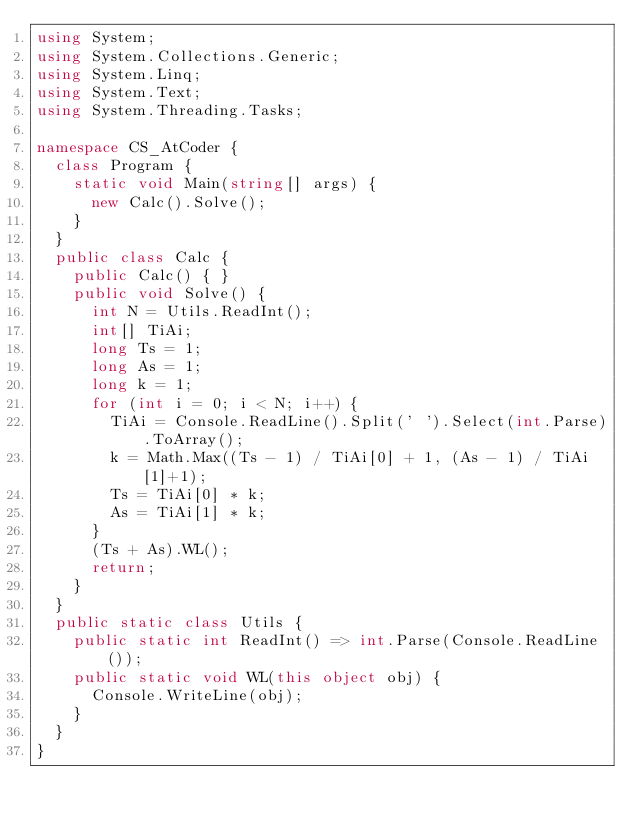<code> <loc_0><loc_0><loc_500><loc_500><_C#_>using System;
using System.Collections.Generic;
using System.Linq;
using System.Text;
using System.Threading.Tasks;

namespace CS_AtCoder {
	class Program {
		static void Main(string[] args) {
			new Calc().Solve();
		}
	}
	public class Calc {
		public Calc() { }
		public void Solve() {
			int N = Utils.ReadInt();
			int[] TiAi;
			long Ts = 1;
			long As = 1;
			long k = 1;
			for (int i = 0; i < N; i++) {
				TiAi = Console.ReadLine().Split(' ').Select(int.Parse).ToArray();
				k = Math.Max((Ts - 1) / TiAi[0] + 1, (As - 1) / TiAi[1]+1);
				Ts = TiAi[0] * k;
				As = TiAi[1] * k;
			}
			(Ts + As).WL();
			return;
		}
	}
	public static class Utils {
		public static int ReadInt() => int.Parse(Console.ReadLine());
		public static void WL(this object obj) {
			Console.WriteLine(obj);
		}
	}
}
</code> 